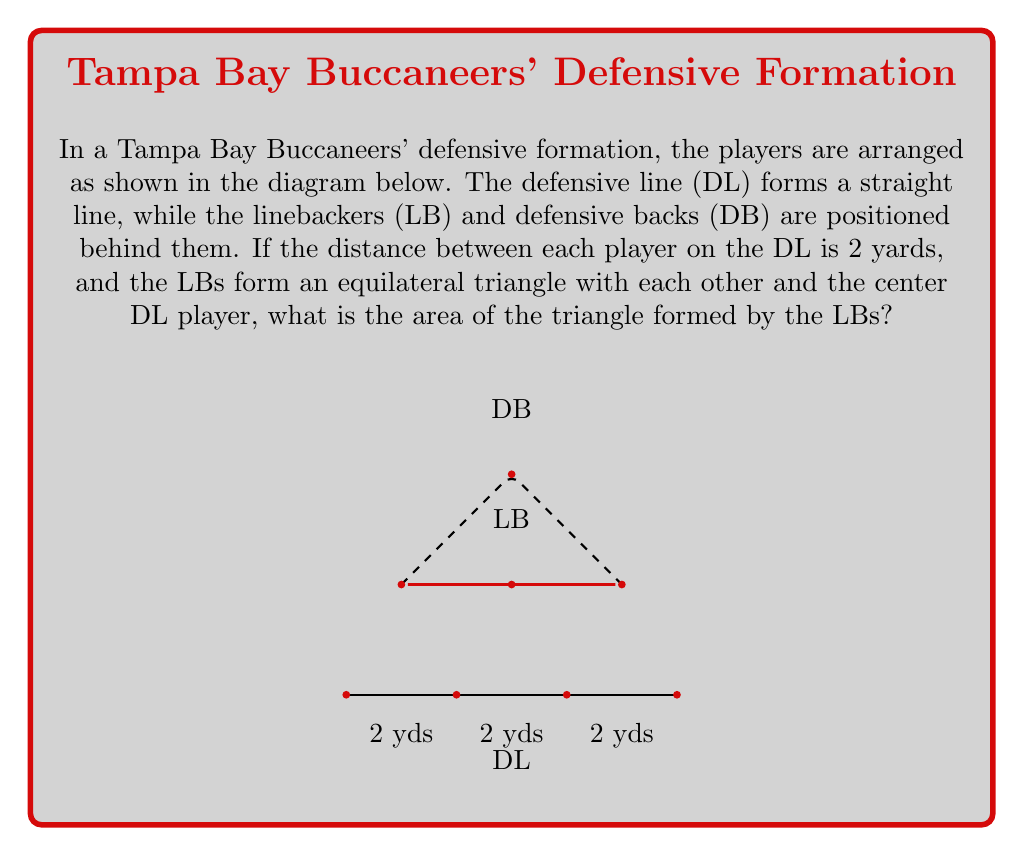Could you help me with this problem? Let's approach this step-by-step:

1) First, we need to determine the side length of the equilateral triangle formed by the LBs.

2) We can see that the base of this triangle is 4 yards long, as it spans the distance of two DL players (2 yards each).

3) In an equilateral triangle, all sides are equal. So, all sides of the LB triangle are 4 yards long.

4) To find the area of an equilateral triangle, we can use the formula:

   $$A = \frac{\sqrt{3}}{4}a^2$$

   Where $a$ is the side length of the triangle.

5) Substituting our side length of 4 yards:

   $$A = \frac{\sqrt{3}}{4}(4^2)$$

6) Simplify:
   $$A = \frac{\sqrt{3}}{4}(16)$$
   $$A = 4\sqrt{3}$$

7) Therefore, the area of the triangle is $4\sqrt{3}$ square yards.
Answer: $4\sqrt{3}$ sq yds 